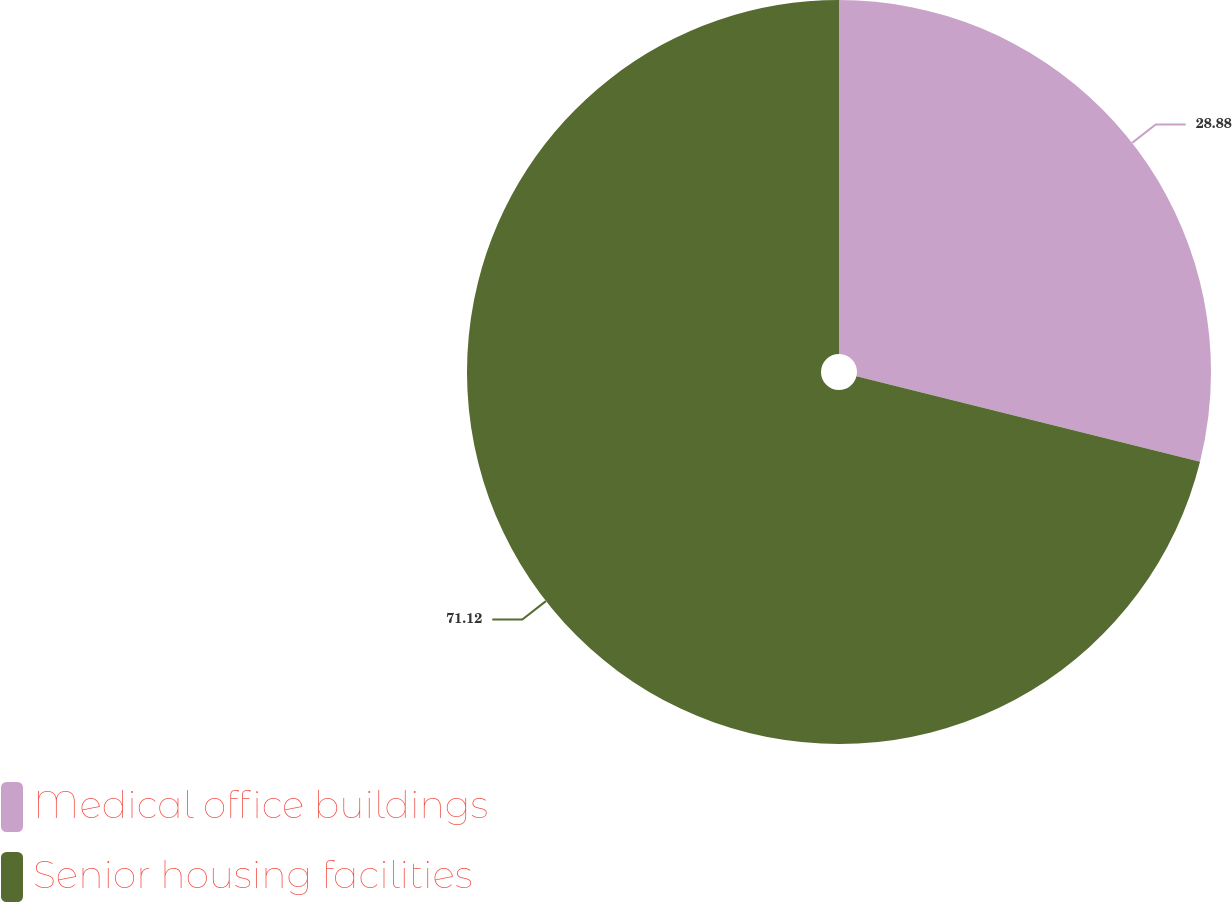Convert chart. <chart><loc_0><loc_0><loc_500><loc_500><pie_chart><fcel>Medical office buildings<fcel>Senior housing facilities<nl><fcel>28.88%<fcel>71.12%<nl></chart> 